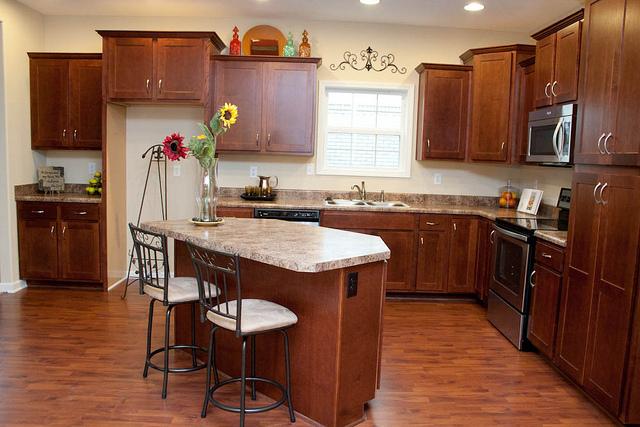Is this a new kitchen?
Write a very short answer. Yes. What type of floor is in this room?
Answer briefly. Wood. Is the counter made of marble?
Keep it brief. Yes. 